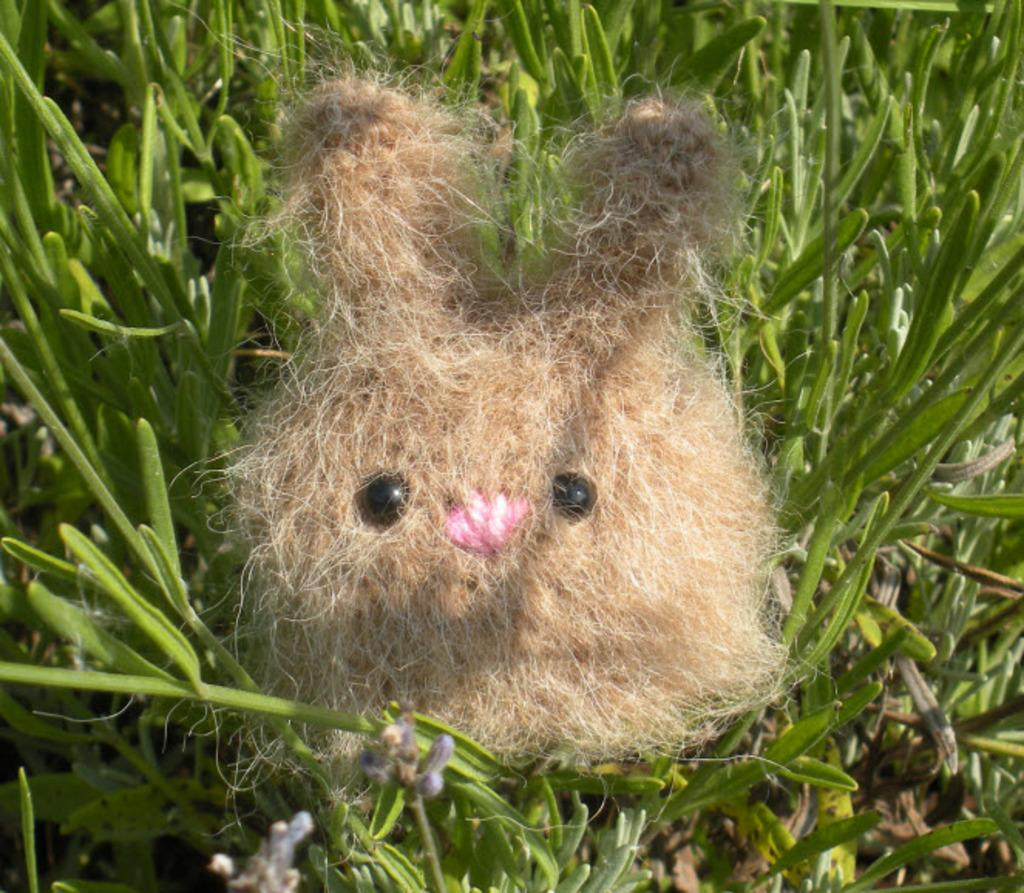What type of living organisms can be seen in the image? Plants can be seen in the image. What stage of growth are the plants in? There are buds in the image, indicating that the plants are in the early stages of growth. What else is present in the image besides plants? There is a toy made with objects in the image. What type of coat is the plant wearing in the image? There is no coat present on the plants in the image. 